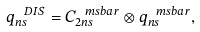<formula> <loc_0><loc_0><loc_500><loc_500>q ^ { \ D I S } _ { n s } = C _ { 2 n s } ^ { \ m s b a r } \otimes q _ { n s } ^ { \ m s b a r } ,</formula> 